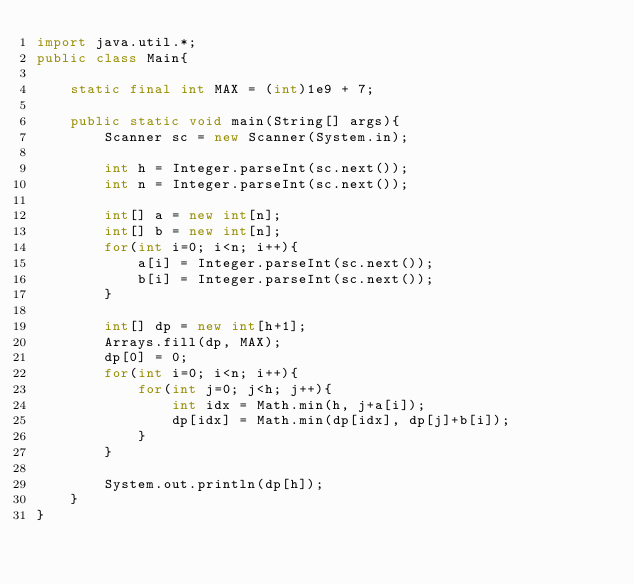Convert code to text. <code><loc_0><loc_0><loc_500><loc_500><_Java_>import java.util.*;
public class Main{
    
    static final int MAX = (int)1e9 + 7;
    
    public static void main(String[] args){
        Scanner sc = new Scanner(System.in);
        
        int h = Integer.parseInt(sc.next());
        int n = Integer.parseInt(sc.next());
        
        int[] a = new int[n];
        int[] b = new int[n];
        for(int i=0; i<n; i++){
            a[i] = Integer.parseInt(sc.next());
            b[i] = Integer.parseInt(sc.next());
        }
        
        int[] dp = new int[h+1];
        Arrays.fill(dp, MAX);
        dp[0] = 0;
        for(int i=0; i<n; i++){
            for(int j=0; j<h; j++){
                int idx = Math.min(h, j+a[i]);
                dp[idx] = Math.min(dp[idx], dp[j]+b[i]);
            }
        }
        
        System.out.println(dp[h]);
    }
}</code> 